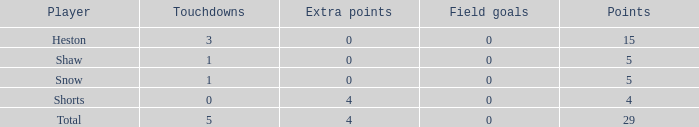What is the sum of all the touchdowns when the player had more than 0 extra points and less than 0 field goals? None. 